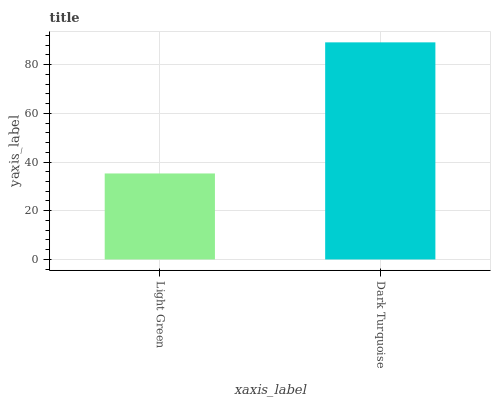Is Light Green the minimum?
Answer yes or no. Yes. Is Dark Turquoise the maximum?
Answer yes or no. Yes. Is Dark Turquoise the minimum?
Answer yes or no. No. Is Dark Turquoise greater than Light Green?
Answer yes or no. Yes. Is Light Green less than Dark Turquoise?
Answer yes or no. Yes. Is Light Green greater than Dark Turquoise?
Answer yes or no. No. Is Dark Turquoise less than Light Green?
Answer yes or no. No. Is Dark Turquoise the high median?
Answer yes or no. Yes. Is Light Green the low median?
Answer yes or no. Yes. Is Light Green the high median?
Answer yes or no. No. Is Dark Turquoise the low median?
Answer yes or no. No. 